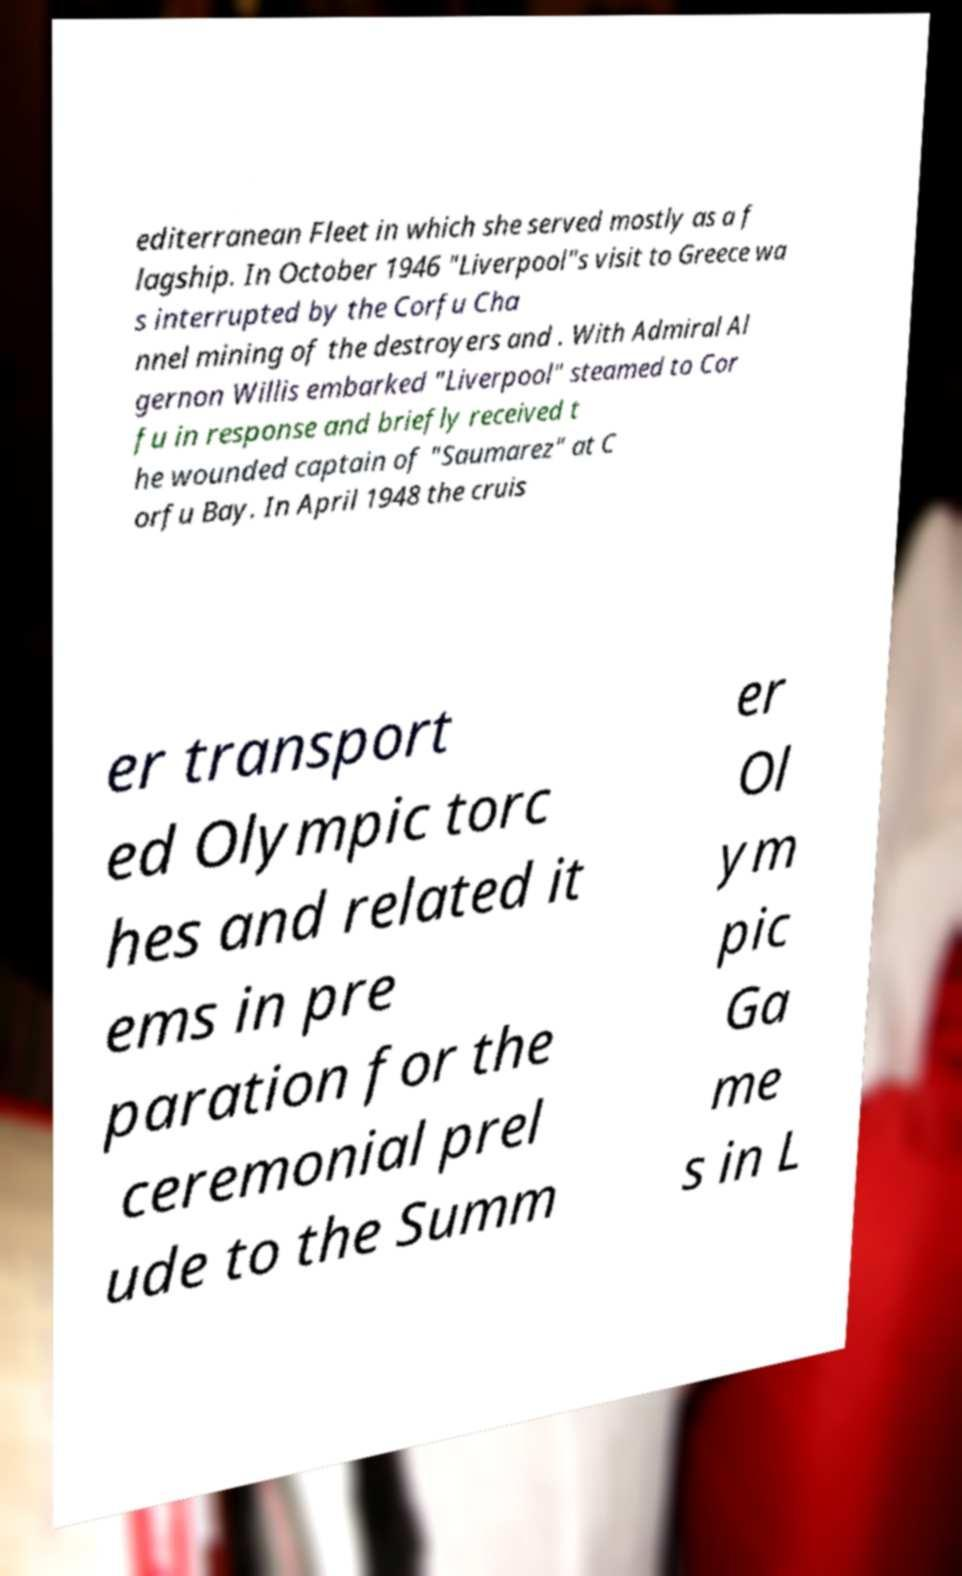Please read and relay the text visible in this image. What does it say? editerranean Fleet in which she served mostly as a f lagship. In October 1946 "Liverpool"s visit to Greece wa s interrupted by the Corfu Cha nnel mining of the destroyers and . With Admiral Al gernon Willis embarked "Liverpool" steamed to Cor fu in response and briefly received t he wounded captain of "Saumarez" at C orfu Bay. In April 1948 the cruis er transport ed Olympic torc hes and related it ems in pre paration for the ceremonial prel ude to the Summ er Ol ym pic Ga me s in L 